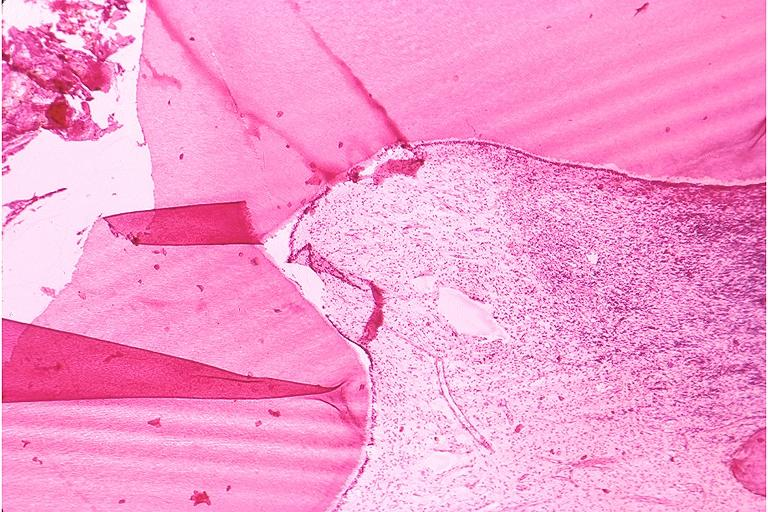does source show chronic pulpitis?
Answer the question using a single word or phrase. No 